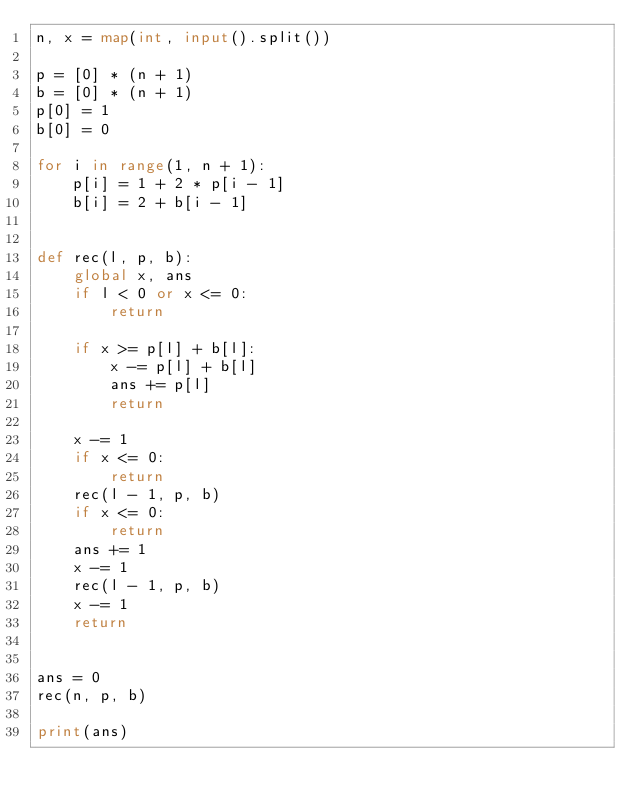<code> <loc_0><loc_0><loc_500><loc_500><_Python_>n, x = map(int, input().split())

p = [0] * (n + 1)
b = [0] * (n + 1)
p[0] = 1
b[0] = 0

for i in range(1, n + 1):
    p[i] = 1 + 2 * p[i - 1]
    b[i] = 2 + b[i - 1]


def rec(l, p, b):
    global x, ans
    if l < 0 or x <= 0:
        return

    if x >= p[l] + b[l]:
        x -= p[l] + b[l]
        ans += p[l]
        return

    x -= 1
    if x <= 0:
        return
    rec(l - 1, p, b)
    if x <= 0:
        return
    ans += 1
    x -= 1
    rec(l - 1, p, b)
    x -= 1
    return


ans = 0
rec(n, p, b)

print(ans)
</code> 